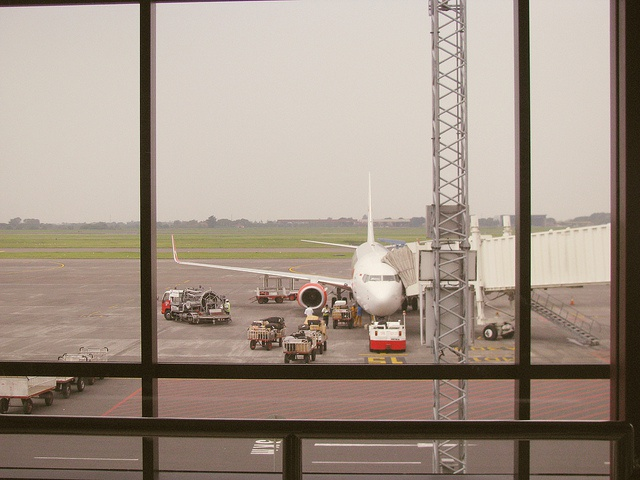Describe the objects in this image and their specific colors. I can see airplane in black, lightgray, darkgray, and tan tones, truck in black, gray, darkgray, and maroon tones, truck in black, gray, maroon, and darkgray tones, truck in black, gray, darkgray, and maroon tones, and truck in black, gray, and maroon tones in this image. 